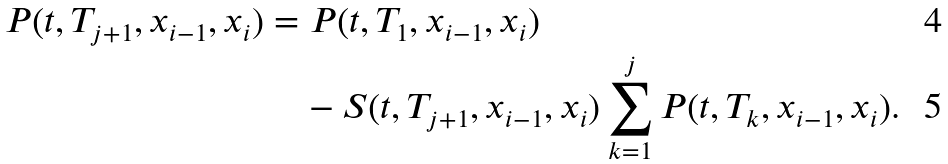<formula> <loc_0><loc_0><loc_500><loc_500>P ( t , T _ { j + 1 } , x _ { i - 1 } , x _ { i } ) & = P ( t , T _ { 1 } , x _ { i - 1 } , x _ { i } ) \\ & \quad - S ( t , T _ { j + 1 } , x _ { i - 1 } , x _ { i } ) \sum _ { k = 1 } ^ { j } P ( t , T _ { k } , x _ { i - 1 } , x _ { i } ) .</formula> 